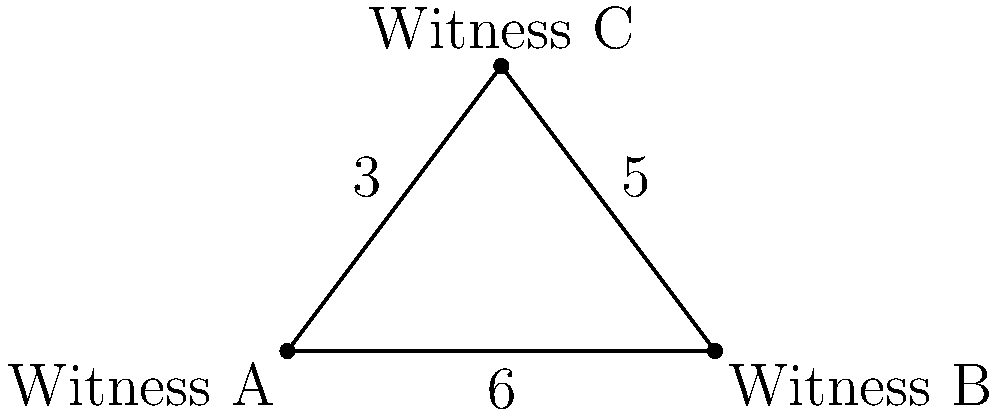In a high-profile case, three witnesses (A, B, and C) are positioned as shown in the diagram. Witness A is 6 units away from Witness B, and Witness C forms a right angle with A and B. If the distance between Witness A and Witness C is 3 units, and the distance between Witness B and Witness C is 5 units, what is the area of the triangle formed by the three witnesses? Express your answer in square units. Let's approach this step-by-step:

1) First, we need to recognize that we have a right triangle. This is key because it allows us to use the Pythagorean theorem.

2) We're given the following information:
   - The distance between A and B (the base of the triangle) is 6 units.
   - The distance between A and C is 3 units.
   - The distance between B and C is 5 units.

3) We can verify that this is indeed a right triangle using the Pythagorean theorem:
   $3^2 + 5^2 = 9 + 25 = 34$
   $6^2 = 36$
   
   Since $3^2 + 5^2 \neq 6^2$, this confirms that the right angle is at C.

4) To find the area of a triangle, we use the formula:
   Area = $\frac{1}{2} \times$ base $\times$ height

5) We know the base (6 units), but we need to find the height. The height is the perpendicular distance from point C to the base AB.

6) We already know this distance - it's 3 units (the distance from A to C).

7) Now we can calculate the area:
   Area = $\frac{1}{2} \times 6 \times 3 = 9$ square units

Therefore, the area of the triangle formed by the three witnesses is 9 square units.
Answer: 9 square units 